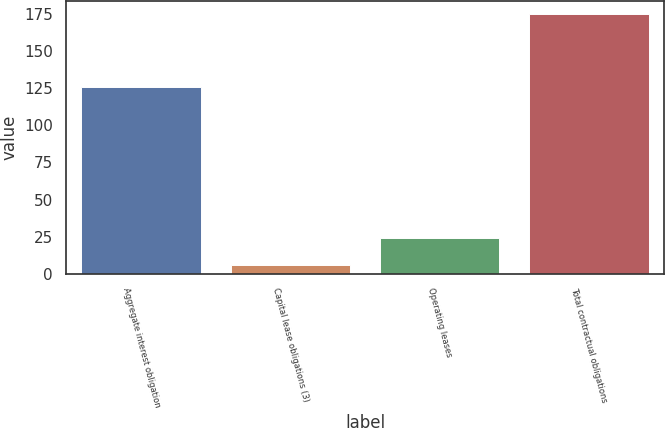Convert chart to OTSL. <chart><loc_0><loc_0><loc_500><loc_500><bar_chart><fcel>Aggregate interest obligation<fcel>Capital lease obligations (3)<fcel>Operating leases<fcel>Total contractual obligations<nl><fcel>126<fcel>6<fcel>24<fcel>175<nl></chart> 